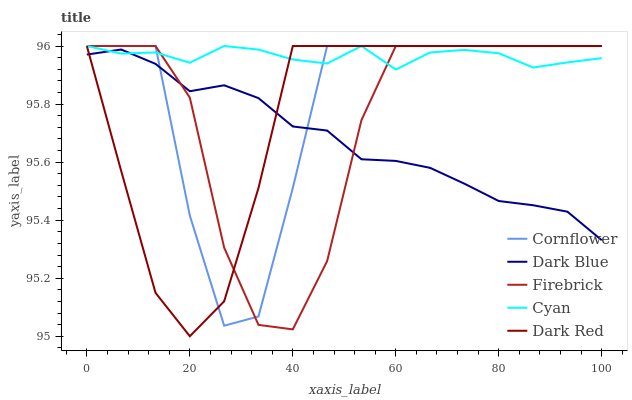Does Dark Blue have the minimum area under the curve?
Answer yes or no. Yes. Does Cyan have the maximum area under the curve?
Answer yes or no. Yes. Does Firebrick have the minimum area under the curve?
Answer yes or no. No. Does Firebrick have the maximum area under the curve?
Answer yes or no. No. Is Dark Blue the smoothest?
Answer yes or no. Yes. Is Cornflower the roughest?
Answer yes or no. Yes. Is Firebrick the smoothest?
Answer yes or no. No. Is Firebrick the roughest?
Answer yes or no. No. Does Firebrick have the lowest value?
Answer yes or no. No. Does Cyan have the highest value?
Answer yes or no. Yes. Does Dark Blue have the highest value?
Answer yes or no. No. 